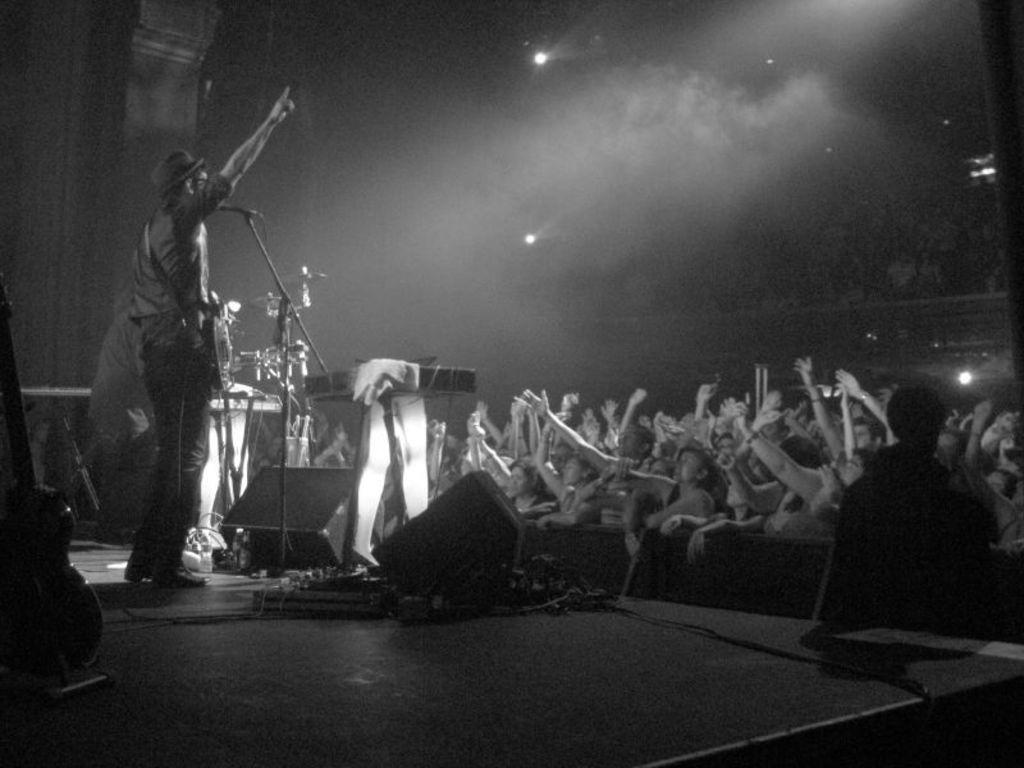Can you describe this image briefly? There is a black and white image. There a person on the left side of the image wearing clothes and standing in front of the mic. There are some audience on the right side of the image raising their hands. There are speakers in the middle of the image. There is a guitar in the bottom left of the image. 